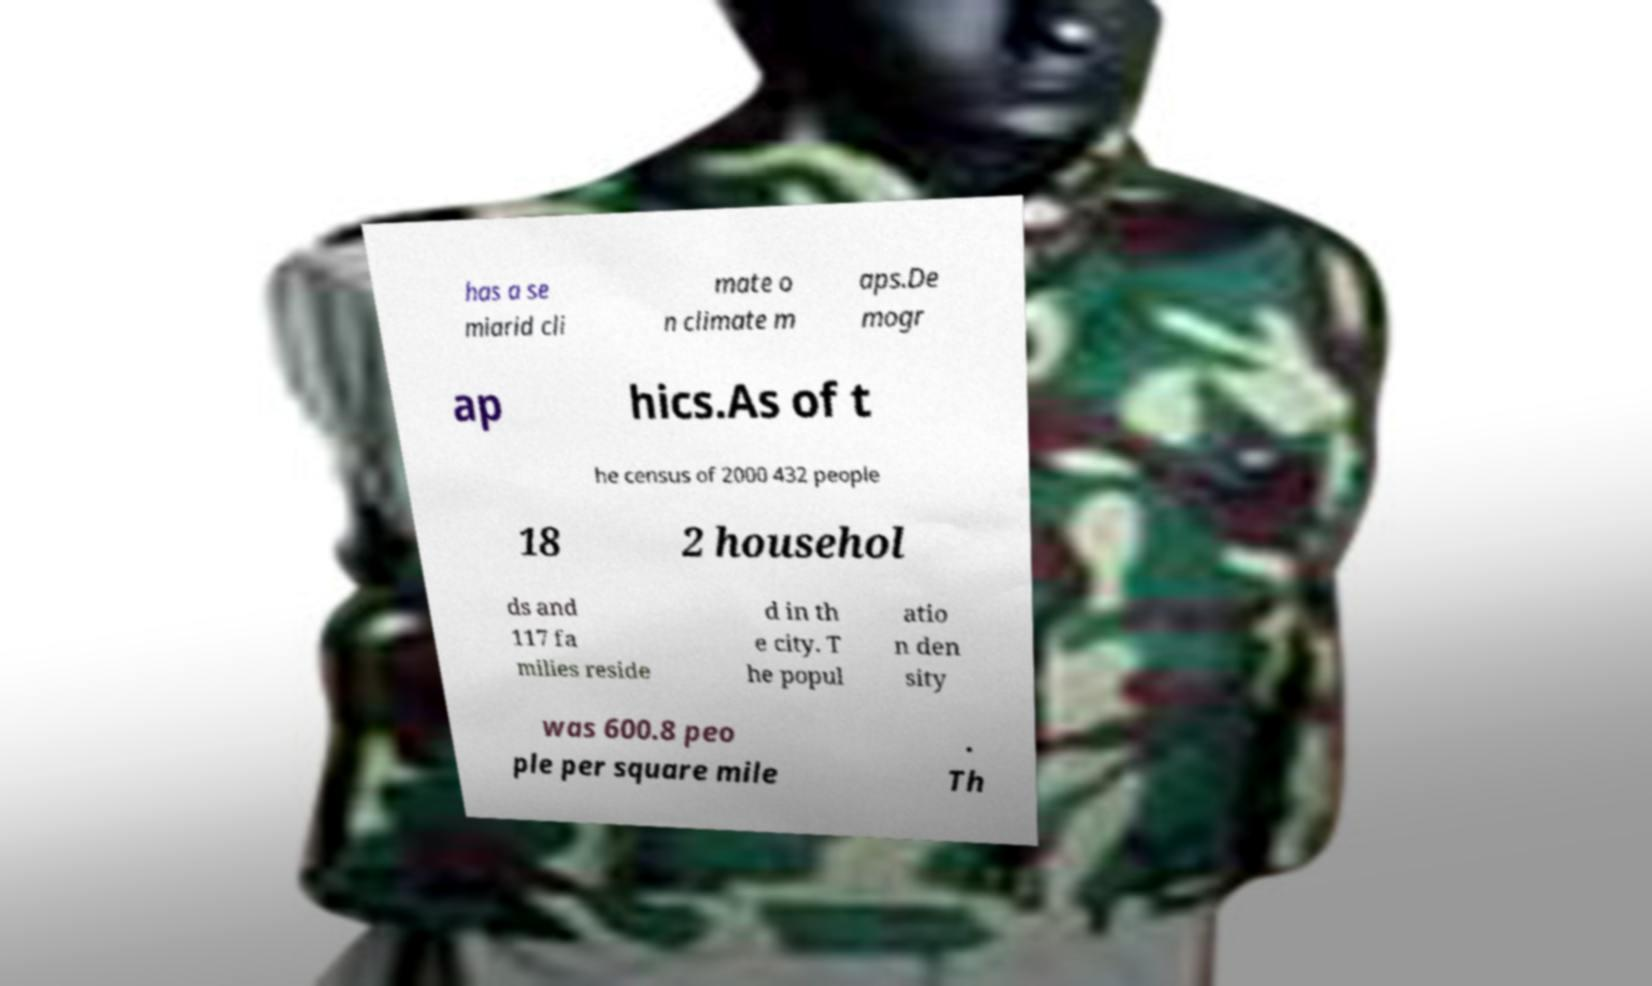For documentation purposes, I need the text within this image transcribed. Could you provide that? has a se miarid cli mate o n climate m aps.De mogr ap hics.As of t he census of 2000 432 people 18 2 househol ds and 117 fa milies reside d in th e city. T he popul atio n den sity was 600.8 peo ple per square mile . Th 